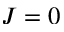<formula> <loc_0><loc_0><loc_500><loc_500>J = 0</formula> 